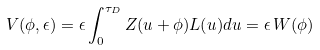Convert formula to latex. <formula><loc_0><loc_0><loc_500><loc_500>V ( \phi , \epsilon ) = \epsilon \int _ { 0 } ^ { \tau _ { D } } Z ( u + \phi ) L ( u ) d u = \epsilon \, W ( \phi )</formula> 